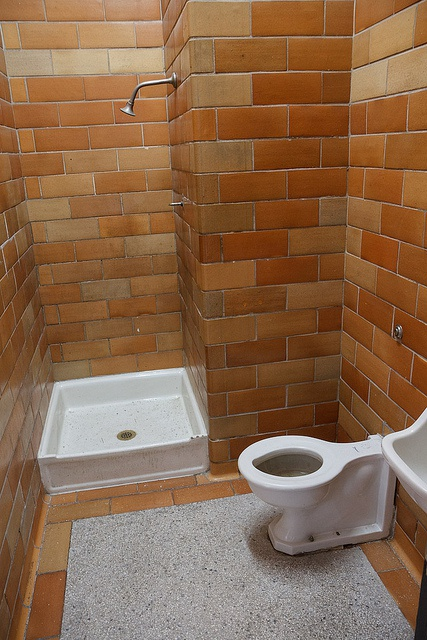Describe the objects in this image and their specific colors. I can see toilet in brown, gray, and lightgray tones and sink in brown, darkgray, lightgray, and gray tones in this image. 